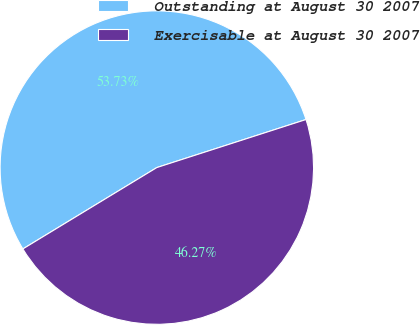Convert chart to OTSL. <chart><loc_0><loc_0><loc_500><loc_500><pie_chart><fcel>Outstanding at August 30 2007<fcel>Exercisable at August 30 2007<nl><fcel>53.73%<fcel>46.27%<nl></chart> 